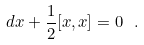Convert formula to latex. <formula><loc_0><loc_0><loc_500><loc_500>d x + \frac { 1 } { 2 } [ x , x ] = 0 \ .</formula> 